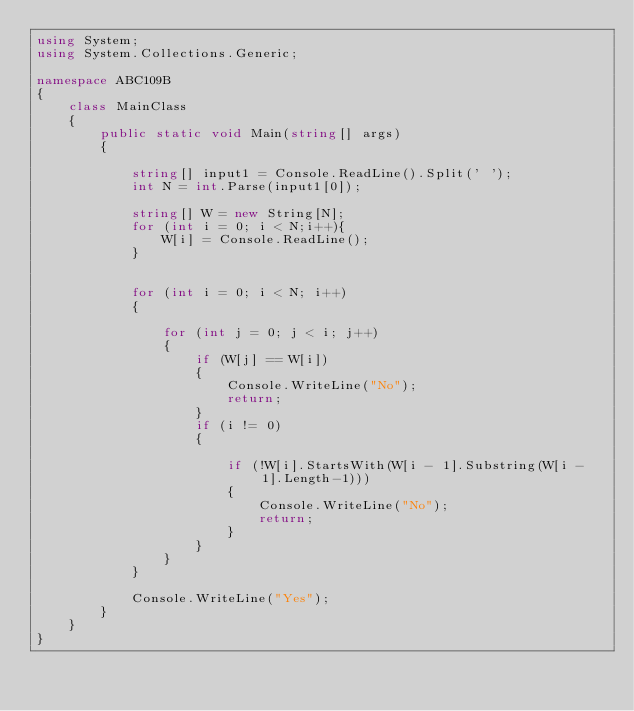Convert code to text. <code><loc_0><loc_0><loc_500><loc_500><_C#_>using System;
using System.Collections.Generic;

namespace ABC109B
{
    class MainClass
    {
        public static void Main(string[] args)
        {

            string[] input1 = Console.ReadLine().Split(' ');
            int N = int.Parse(input1[0]);

            string[] W = new String[N];
            for (int i = 0; i < N;i++){
                W[i] = Console.ReadLine();
            }


            for (int i = 0; i < N; i++)
            {

                for (int j = 0; j < i; j++)
                {
                    if (W[j] == W[i])
                    {
                        Console.WriteLine("No");
                        return;
                    }
                    if (i != 0)
                    {

                        if (!W[i].StartsWith(W[i - 1].Substring(W[i - 1].Length-1)))   
                        {
                            Console.WriteLine("No");
                            return;
                        }
                    }
                }
            }

            Console.WriteLine("Yes");
        }
    }
}


</code> 